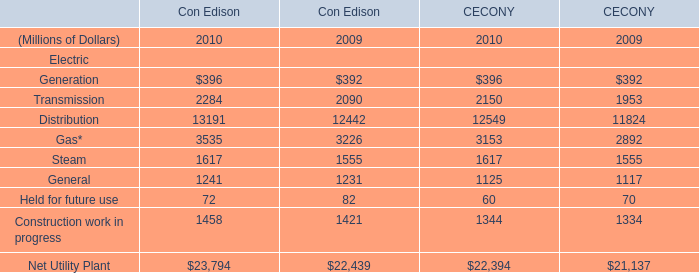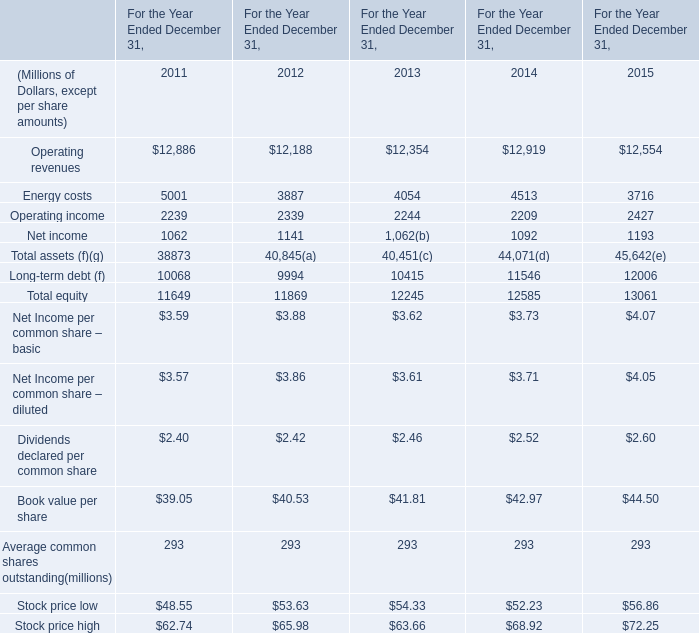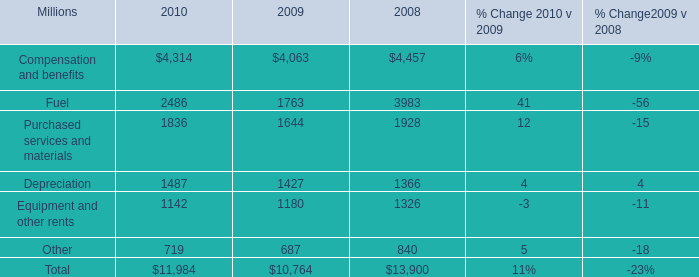In which years is Operating income greater than Net income? 
Answer: 2011;2012;2013;2014;2015. 